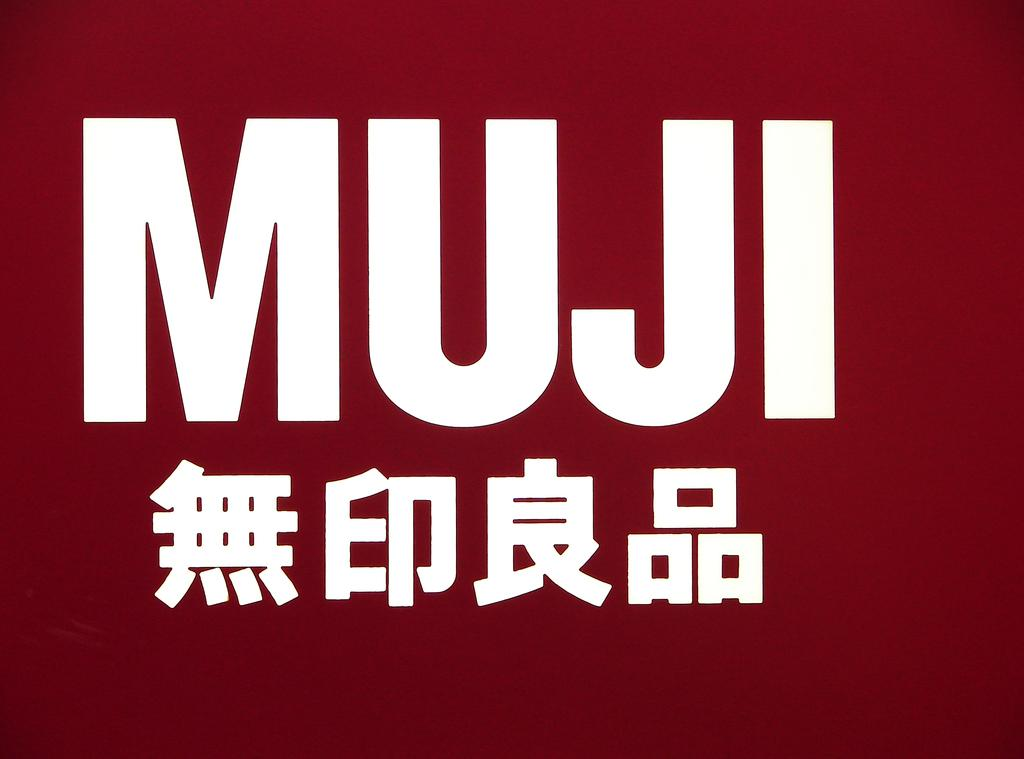What can be found on the image? There is text on the image. Can you see a person sorting flies in the image? There is no person or flies present in the image; it only contains text. 